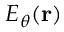<formula> <loc_0><loc_0><loc_500><loc_500>E _ { \theta } ( { r } )</formula> 